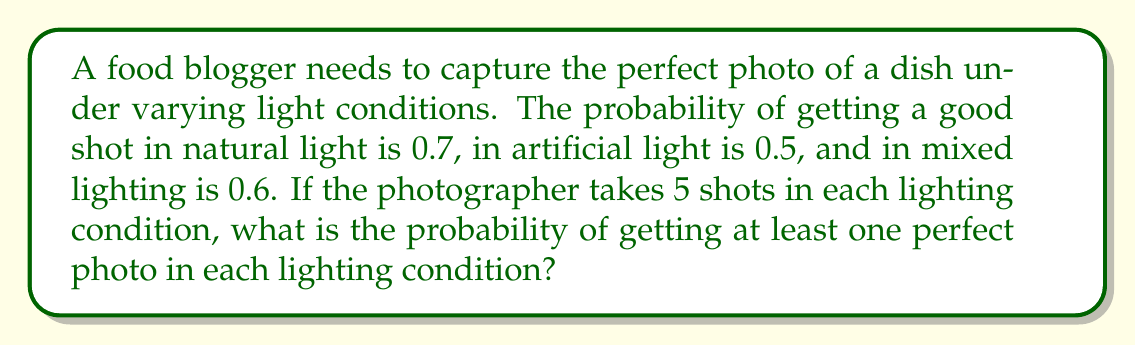Give your solution to this math problem. Let's approach this step-by-step:

1) First, we need to calculate the probability of not getting a perfect photo in each lighting condition:
   - Natural light: $1 - 0.7 = 0.3$
   - Artificial light: $1 - 0.5 = 0.5$
   - Mixed lighting: $1 - 0.6 = 0.4$

2) Now, we need to calculate the probability of not getting a perfect photo in 5 shots for each condition:
   - Natural light: $0.3^5 = 0.00243$
   - Artificial light: $0.5^5 = 0.03125$
   - Mixed lighting: $0.4^5 = 0.01024$

3) The probability of getting at least one perfect photo in 5 shots for each condition is:
   - Natural light: $1 - 0.00243 = 0.99757$
   - Artificial light: $1 - 0.03125 = 0.96875$
   - Mixed lighting: $1 - 0.01024 = 0.98976$

4) The probability of getting at least one perfect photo in each lighting condition is the product of these probabilities:

   $$P(\text{at least one in each}) = 0.99757 \times 0.96875 \times 0.98976 = 0.95667$$

5) Therefore, the probability is approximately 0.95667 or 95.67%.
Answer: 0.95667 